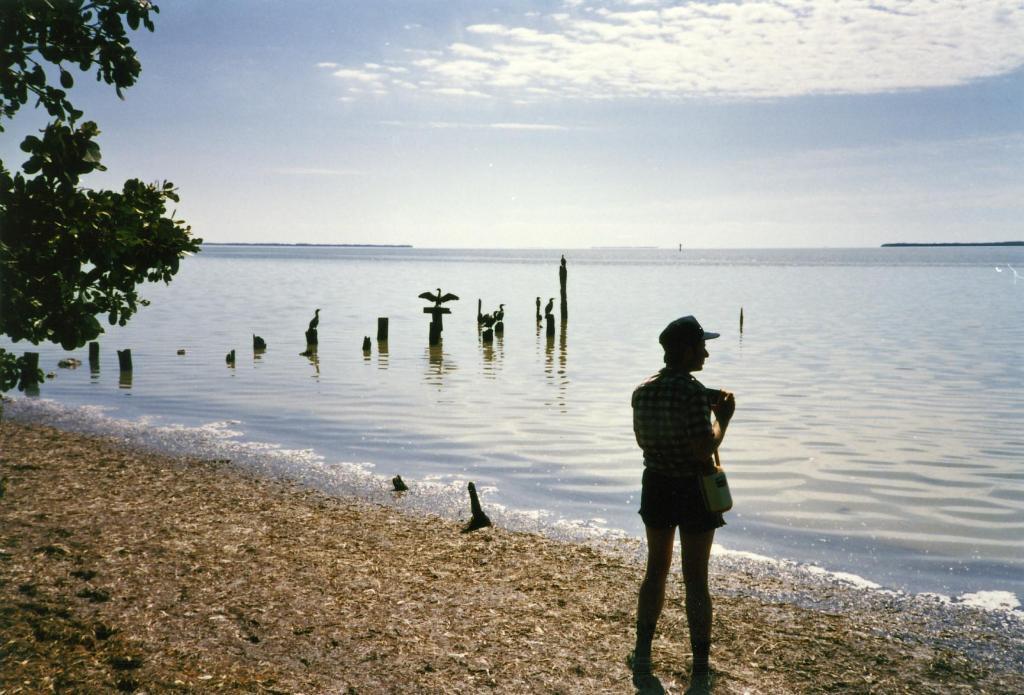Could you give a brief overview of what you see in this image? In this image in the front there is a man standing. On the left side there are leaves. In the background there is water and there are birds and the sky is cloudy. 